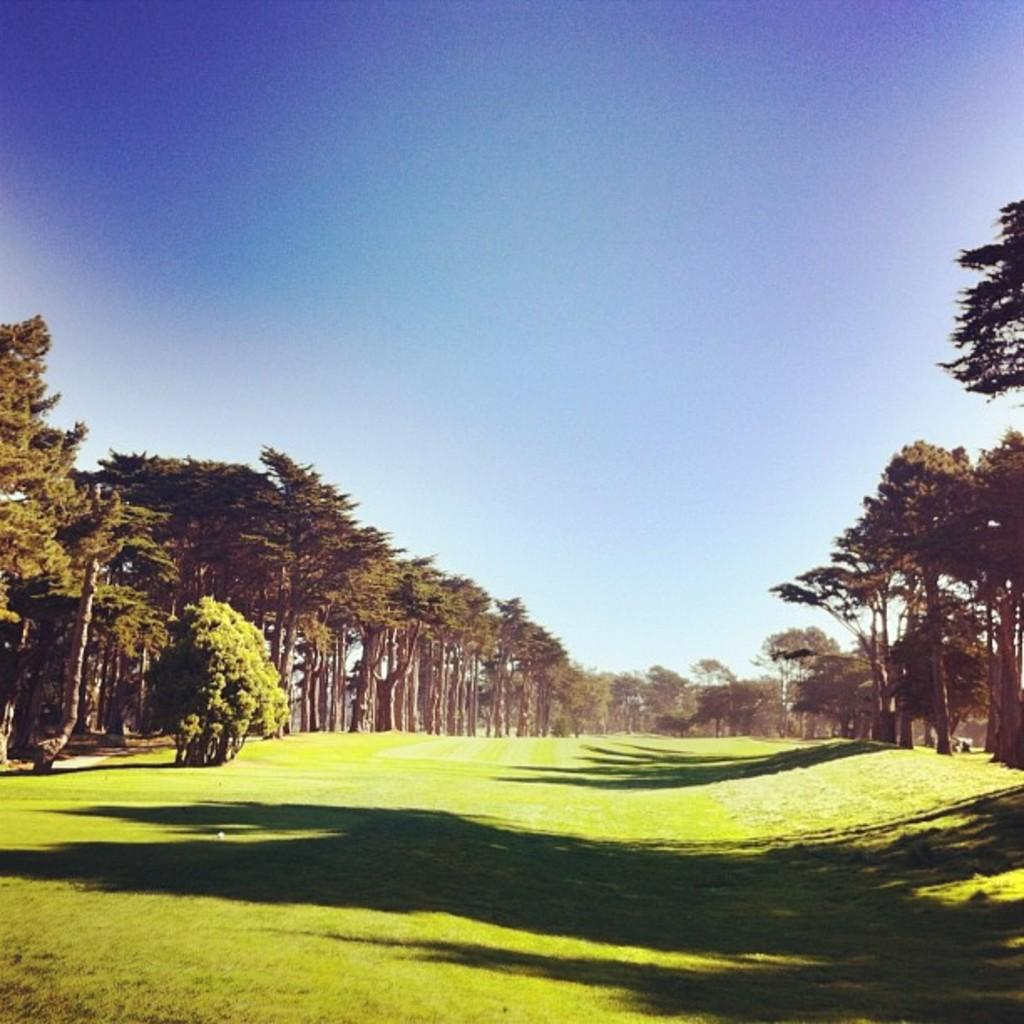What is the main setting of the image? There is a garden in the image. What can be seen surrounding the garden? There are many trees around the garden. What type of chess pieces can be seen on the wrist of the person in the image? There is no person or chess pieces present in the image; it features a garden with many trees. 